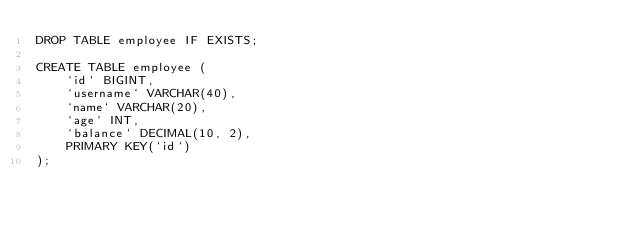<code> <loc_0><loc_0><loc_500><loc_500><_SQL_>DROP TABLE employee IF EXISTS;

CREATE TABLE employee (
    `id` BIGINT,
    `username` VARCHAR(40),
    `name` VARCHAR(20),
    `age` INT,
    `balance` DECIMAL(10, 2),
    PRIMARY KEY(`id`)
);</code> 